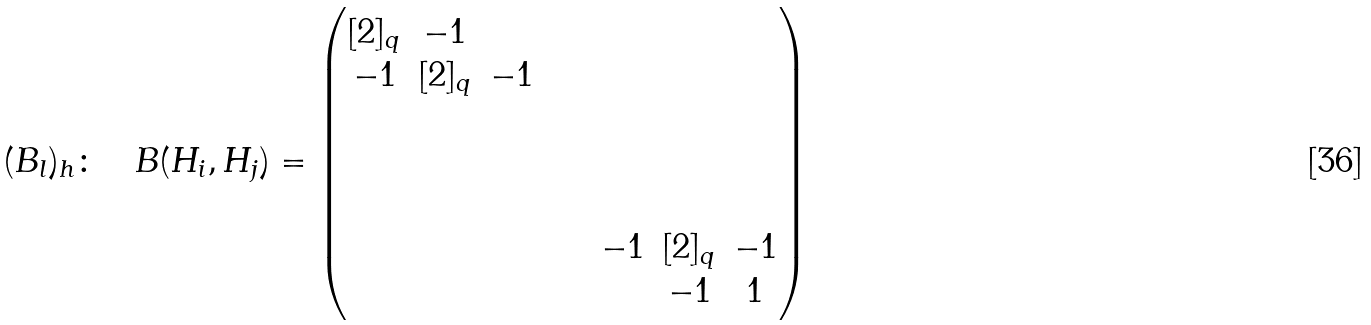Convert formula to latex. <formula><loc_0><loc_0><loc_500><loc_500>( B _ { l } ) _ { h } \colon \quad B ( H _ { i } , H _ { j } ) = \begin{pmatrix} [ 2 ] _ { q } & - 1 & & & & & & & \\ - 1 & [ 2 ] _ { q } & - 1 & & & & & & \\ & & & & & & & & \\ & & & & & & & & \\ & & & & & & & & \\ & & & & & & - 1 & [ 2 ] _ { q } & - 1 \\ & & & & & & & - 1 & 1 \end{pmatrix}</formula> 